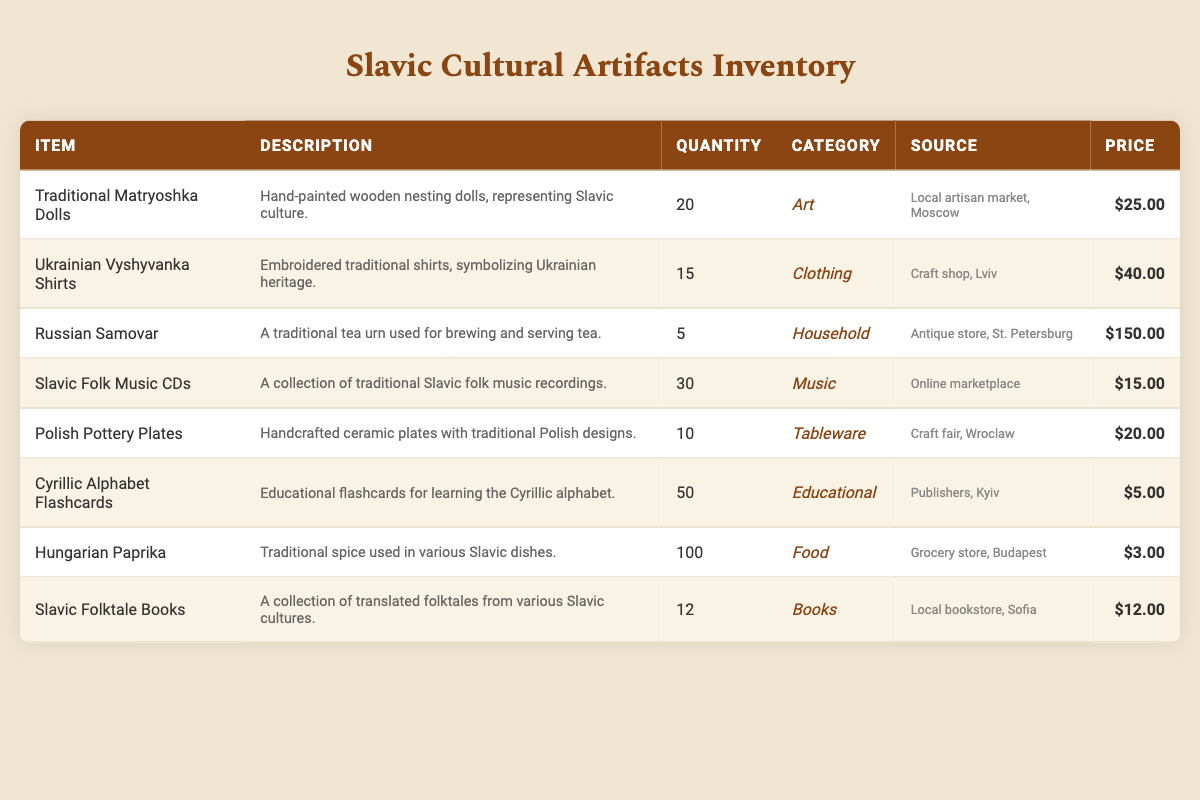What is the total quantity of Traditional Matryoshka Dolls? The quantity of Traditional Matryoshka Dolls is listed in the table as 20.
Answer: 20 Which item has the highest price per item? The highest price listed in the table is for the Russian Samovar at $150.00.
Answer: Russian Samovar Are there more than 50 Cyrillic Alphabet Flashcards available? The quantity of Cyrillic Alphabet Flashcards is 50, which is not more than 50, therefore the answer is no.
Answer: No What is the combined quantity of Ukrainian Vyshyvanka Shirts and Polish Pottery Plates? The quantity of Ukrainian Vyshyvanka Shirts is 15 and Polish Pottery Plates is 10. Adding them gives 15 + 10 = 25.
Answer: 25 Is there a category that contains more than 100 items? The Food category has Hungarian Paprika with a quantity of 100, so it does not exceed 100. Therefore, the answer is no.
Answer: No What is the total value of all the items in the inventory? To find the total value, we sum the products of quantity and price per item for each item: (20 * 25) + (15 * 40) + (5 * 150) + (30 * 15) + (10 * 20) + (50 * 5) + (100 * 3) + (12 * 12) = 500 + 600 + 750 + 450 + 200 + 250 + 300 + 144 = 3194.
Answer: 3194 How many items are available in the Music category? Only the Slavic Folk Music CDs are listed under the Music category, which shows a quantity of 30.
Answer: 30 What item has a quantity of 10 and belongs to the Tableware category? The item with a quantity of 10 in the Tableware category is Polish Pottery Plates.
Answer: Polish Pottery Plates 